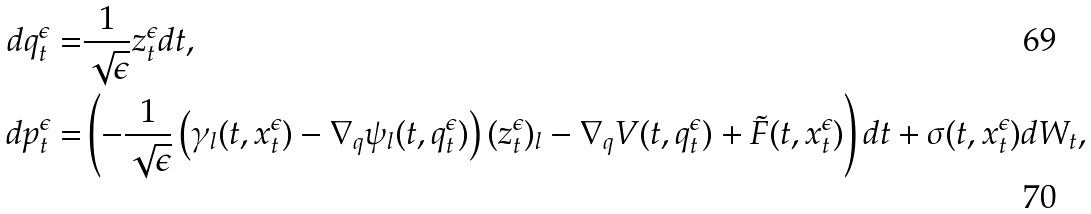Convert formula to latex. <formula><loc_0><loc_0><loc_500><loc_500>d q ^ { \epsilon } _ { t } = & \frac { 1 } { \sqrt { \epsilon } } z _ { t } ^ { \epsilon } d t , \\ d p ^ { \epsilon } _ { t } = & \left ( - \frac { 1 } { \sqrt { \epsilon } } \left ( \gamma _ { l } ( t , x ^ { \epsilon } _ { t } ) - \nabla _ { q } \psi _ { l } ( t , q _ { t } ^ { \epsilon } ) \right ) ( z _ { t } ^ { \epsilon } ) _ { l } - \nabla _ { q } V ( t , q ^ { \epsilon } _ { t } ) + \tilde { F } ( t , x ^ { \epsilon } _ { t } ) \right ) d t + \sigma ( t , x ^ { \epsilon } _ { t } ) d W _ { t } ,</formula> 